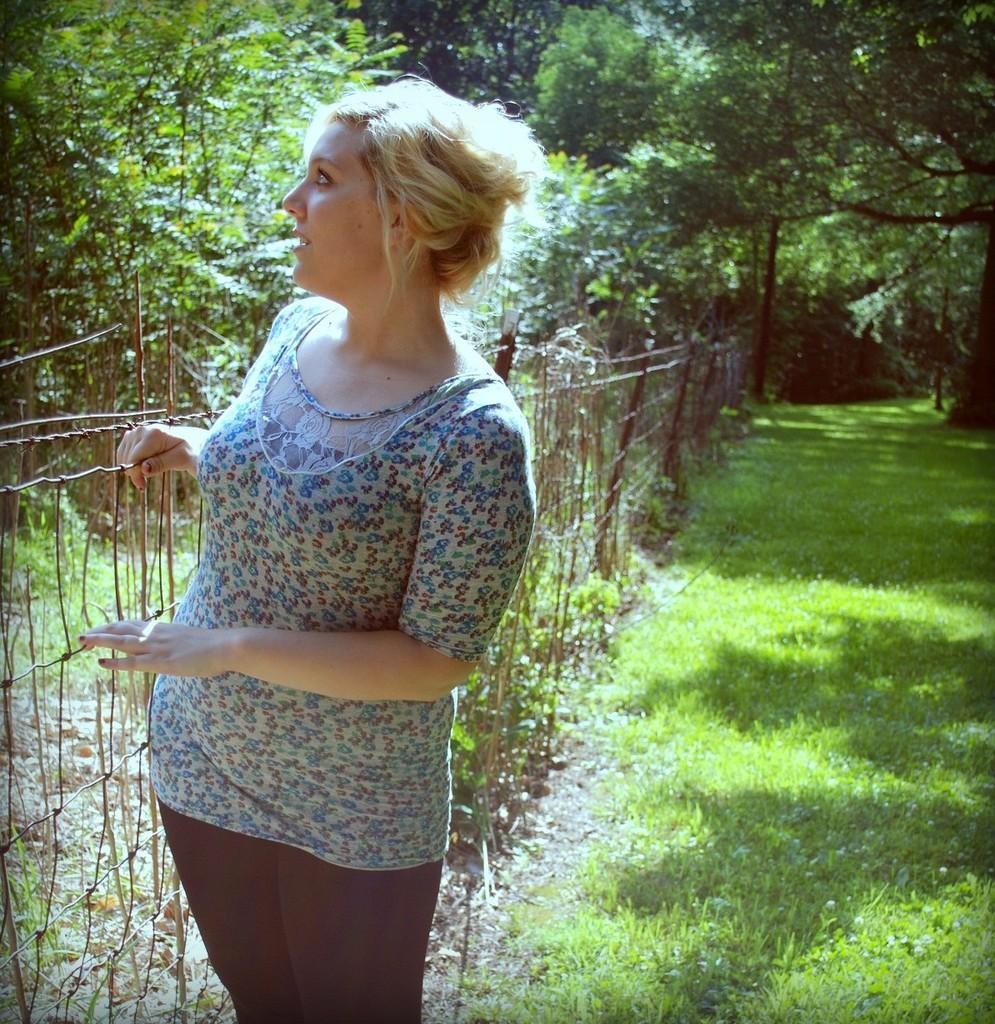Who is in the image? There is a woman in the image. What can be seen in the background of the image? There is a fence, grass, and trees in the background of the image. What type of test can be seen on the woman's boot in the image? There is no boot or test present in the image; it only features a woman and background elements. 